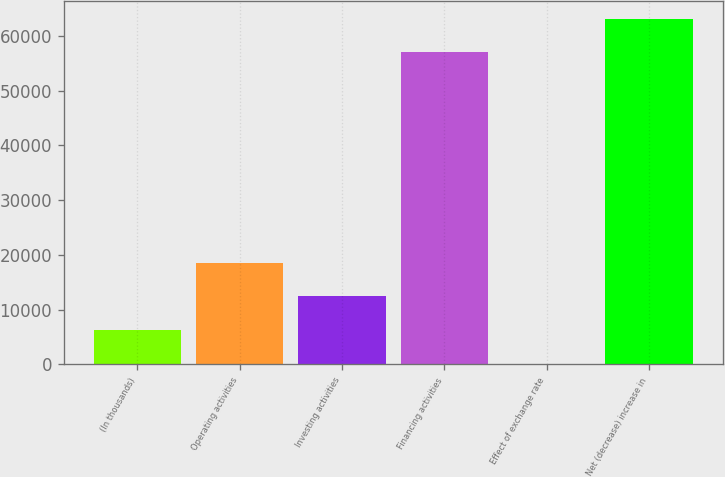<chart> <loc_0><loc_0><loc_500><loc_500><bar_chart><fcel>(In thousands)<fcel>Operating activities<fcel>Investing activities<fcel>Financing activities<fcel>Effect of exchange rate<fcel>Net (decrease) increase in<nl><fcel>6242.3<fcel>18608.9<fcel>12425.6<fcel>56989<fcel>59<fcel>63172.3<nl></chart> 